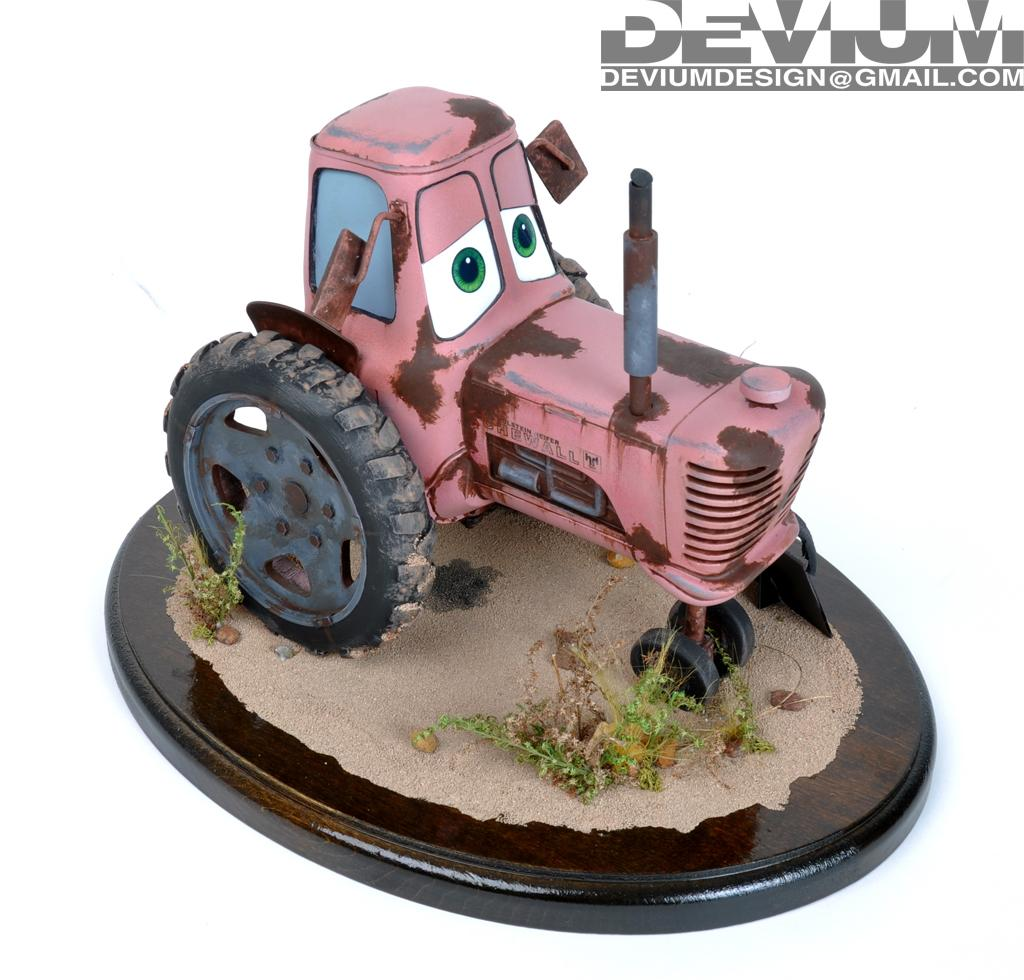What is the color of the surface in the image? The surface in the image is brown. What type of material covers the surface? There is sand on the surface. Are there any living organisms visible on the surface? Yes, there are plants on the surface. What type of vehicle can be seen in the image? There is a toy tractor in the image. Is there any additional information or markings on the image? Yes, there is a watermark in the top right corner of the image. What street is shown in the image? There is no street visible in the image; it features a brown surface with sand, plants, and a toy tractor. 